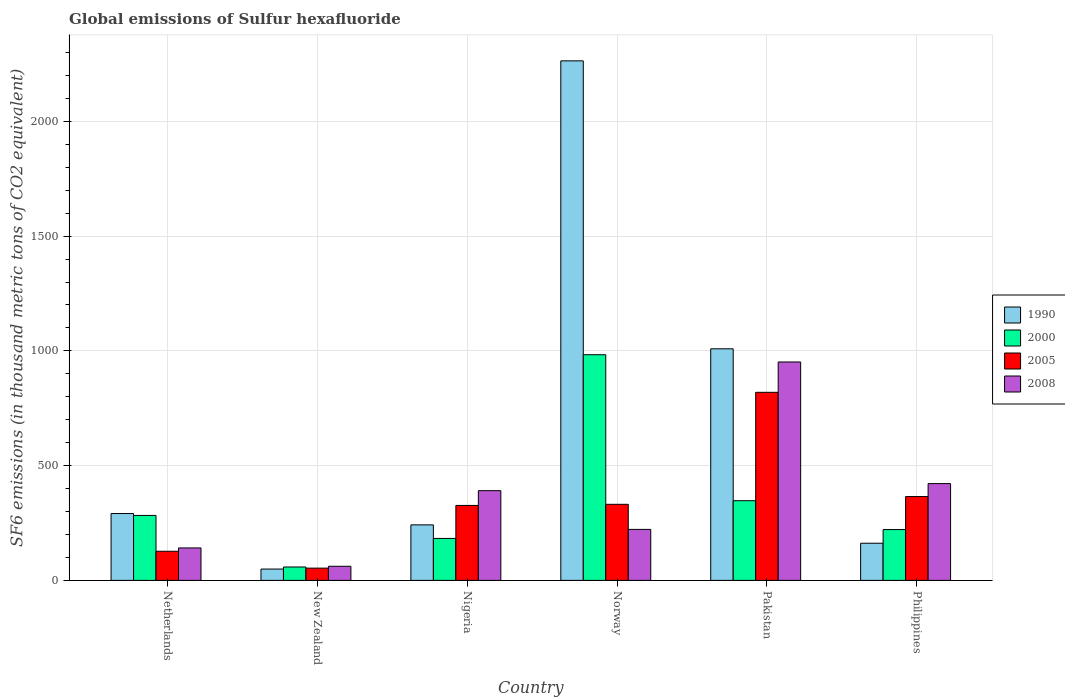How many different coloured bars are there?
Make the answer very short. 4. Are the number of bars per tick equal to the number of legend labels?
Provide a succinct answer. Yes. Are the number of bars on each tick of the X-axis equal?
Make the answer very short. Yes. In how many cases, is the number of bars for a given country not equal to the number of legend labels?
Your answer should be very brief. 0. What is the global emissions of Sulfur hexafluoride in 1990 in Norway?
Keep it short and to the point. 2263.6. Across all countries, what is the maximum global emissions of Sulfur hexafluoride in 2008?
Ensure brevity in your answer.  951.6. Across all countries, what is the minimum global emissions of Sulfur hexafluoride in 2005?
Offer a terse response. 53.4. In which country was the global emissions of Sulfur hexafluoride in 2008 maximum?
Provide a short and direct response. Pakistan. In which country was the global emissions of Sulfur hexafluoride in 1990 minimum?
Your answer should be compact. New Zealand. What is the total global emissions of Sulfur hexafluoride in 2008 in the graph?
Ensure brevity in your answer.  2189.3. What is the difference between the global emissions of Sulfur hexafluoride in 2005 in New Zealand and that in Philippines?
Your answer should be compact. -311.9. What is the difference between the global emissions of Sulfur hexafluoride in 1990 in Philippines and the global emissions of Sulfur hexafluoride in 2000 in New Zealand?
Provide a succinct answer. 103.5. What is the average global emissions of Sulfur hexafluoride in 1990 per country?
Keep it short and to the point. 669.52. What is the difference between the global emissions of Sulfur hexafluoride of/in 1990 and global emissions of Sulfur hexafluoride of/in 2008 in New Zealand?
Provide a succinct answer. -12.1. What is the ratio of the global emissions of Sulfur hexafluoride in 1990 in New Zealand to that in Philippines?
Offer a terse response. 0.31. Is the global emissions of Sulfur hexafluoride in 2000 in Netherlands less than that in New Zealand?
Offer a terse response. No. What is the difference between the highest and the second highest global emissions of Sulfur hexafluoride in 2005?
Offer a very short reply. -488. What is the difference between the highest and the lowest global emissions of Sulfur hexafluoride in 2005?
Offer a very short reply. 766. What does the 1st bar from the right in Nigeria represents?
Offer a terse response. 2008. Is it the case that in every country, the sum of the global emissions of Sulfur hexafluoride in 2008 and global emissions of Sulfur hexafluoride in 2000 is greater than the global emissions of Sulfur hexafluoride in 1990?
Ensure brevity in your answer.  No. How many bars are there?
Your response must be concise. 24. How many countries are there in the graph?
Give a very brief answer. 6. Are the values on the major ticks of Y-axis written in scientific E-notation?
Your answer should be very brief. No. Does the graph contain any zero values?
Offer a very short reply. No. Does the graph contain grids?
Ensure brevity in your answer.  Yes. Where does the legend appear in the graph?
Give a very brief answer. Center right. How are the legend labels stacked?
Ensure brevity in your answer.  Vertical. What is the title of the graph?
Your answer should be very brief. Global emissions of Sulfur hexafluoride. Does "1980" appear as one of the legend labels in the graph?
Your response must be concise. No. What is the label or title of the Y-axis?
Offer a very short reply. SF6 emissions (in thousand metric tons of CO2 equivalent). What is the SF6 emissions (in thousand metric tons of CO2 equivalent) in 1990 in Netherlands?
Your answer should be compact. 291.3. What is the SF6 emissions (in thousand metric tons of CO2 equivalent) of 2000 in Netherlands?
Make the answer very short. 283. What is the SF6 emissions (in thousand metric tons of CO2 equivalent) of 2005 in Netherlands?
Your answer should be compact. 126.9. What is the SF6 emissions (in thousand metric tons of CO2 equivalent) of 2008 in Netherlands?
Your answer should be very brief. 141.4. What is the SF6 emissions (in thousand metric tons of CO2 equivalent) of 1990 in New Zealand?
Offer a very short reply. 49.4. What is the SF6 emissions (in thousand metric tons of CO2 equivalent) in 2000 in New Zealand?
Your answer should be very brief. 58.4. What is the SF6 emissions (in thousand metric tons of CO2 equivalent) of 2005 in New Zealand?
Your answer should be compact. 53.4. What is the SF6 emissions (in thousand metric tons of CO2 equivalent) in 2008 in New Zealand?
Offer a terse response. 61.5. What is the SF6 emissions (in thousand metric tons of CO2 equivalent) of 1990 in Nigeria?
Your answer should be compact. 241.9. What is the SF6 emissions (in thousand metric tons of CO2 equivalent) of 2000 in Nigeria?
Make the answer very short. 182.8. What is the SF6 emissions (in thousand metric tons of CO2 equivalent) in 2005 in Nigeria?
Make the answer very short. 326.6. What is the SF6 emissions (in thousand metric tons of CO2 equivalent) of 2008 in Nigeria?
Provide a succinct answer. 390.9. What is the SF6 emissions (in thousand metric tons of CO2 equivalent) in 1990 in Norway?
Provide a succinct answer. 2263.6. What is the SF6 emissions (in thousand metric tons of CO2 equivalent) in 2000 in Norway?
Offer a terse response. 983.2. What is the SF6 emissions (in thousand metric tons of CO2 equivalent) of 2005 in Norway?
Your response must be concise. 331.4. What is the SF6 emissions (in thousand metric tons of CO2 equivalent) in 2008 in Norway?
Your answer should be very brief. 222.2. What is the SF6 emissions (in thousand metric tons of CO2 equivalent) in 1990 in Pakistan?
Provide a short and direct response. 1009. What is the SF6 emissions (in thousand metric tons of CO2 equivalent) in 2000 in Pakistan?
Ensure brevity in your answer.  347.2. What is the SF6 emissions (in thousand metric tons of CO2 equivalent) of 2005 in Pakistan?
Provide a succinct answer. 819.4. What is the SF6 emissions (in thousand metric tons of CO2 equivalent) of 2008 in Pakistan?
Offer a terse response. 951.6. What is the SF6 emissions (in thousand metric tons of CO2 equivalent) of 1990 in Philippines?
Your answer should be compact. 161.9. What is the SF6 emissions (in thousand metric tons of CO2 equivalent) in 2000 in Philippines?
Offer a very short reply. 221.4. What is the SF6 emissions (in thousand metric tons of CO2 equivalent) of 2005 in Philippines?
Your answer should be compact. 365.3. What is the SF6 emissions (in thousand metric tons of CO2 equivalent) in 2008 in Philippines?
Offer a very short reply. 421.7. Across all countries, what is the maximum SF6 emissions (in thousand metric tons of CO2 equivalent) in 1990?
Offer a very short reply. 2263.6. Across all countries, what is the maximum SF6 emissions (in thousand metric tons of CO2 equivalent) in 2000?
Your answer should be very brief. 983.2. Across all countries, what is the maximum SF6 emissions (in thousand metric tons of CO2 equivalent) of 2005?
Provide a short and direct response. 819.4. Across all countries, what is the maximum SF6 emissions (in thousand metric tons of CO2 equivalent) in 2008?
Keep it short and to the point. 951.6. Across all countries, what is the minimum SF6 emissions (in thousand metric tons of CO2 equivalent) of 1990?
Ensure brevity in your answer.  49.4. Across all countries, what is the minimum SF6 emissions (in thousand metric tons of CO2 equivalent) of 2000?
Offer a very short reply. 58.4. Across all countries, what is the minimum SF6 emissions (in thousand metric tons of CO2 equivalent) of 2005?
Keep it short and to the point. 53.4. Across all countries, what is the minimum SF6 emissions (in thousand metric tons of CO2 equivalent) of 2008?
Your answer should be very brief. 61.5. What is the total SF6 emissions (in thousand metric tons of CO2 equivalent) in 1990 in the graph?
Your answer should be very brief. 4017.1. What is the total SF6 emissions (in thousand metric tons of CO2 equivalent) of 2000 in the graph?
Your answer should be compact. 2076. What is the total SF6 emissions (in thousand metric tons of CO2 equivalent) of 2005 in the graph?
Offer a terse response. 2023. What is the total SF6 emissions (in thousand metric tons of CO2 equivalent) in 2008 in the graph?
Your answer should be compact. 2189.3. What is the difference between the SF6 emissions (in thousand metric tons of CO2 equivalent) of 1990 in Netherlands and that in New Zealand?
Your response must be concise. 241.9. What is the difference between the SF6 emissions (in thousand metric tons of CO2 equivalent) in 2000 in Netherlands and that in New Zealand?
Your answer should be very brief. 224.6. What is the difference between the SF6 emissions (in thousand metric tons of CO2 equivalent) of 2005 in Netherlands and that in New Zealand?
Give a very brief answer. 73.5. What is the difference between the SF6 emissions (in thousand metric tons of CO2 equivalent) of 2008 in Netherlands and that in New Zealand?
Keep it short and to the point. 79.9. What is the difference between the SF6 emissions (in thousand metric tons of CO2 equivalent) in 1990 in Netherlands and that in Nigeria?
Your answer should be compact. 49.4. What is the difference between the SF6 emissions (in thousand metric tons of CO2 equivalent) in 2000 in Netherlands and that in Nigeria?
Keep it short and to the point. 100.2. What is the difference between the SF6 emissions (in thousand metric tons of CO2 equivalent) in 2005 in Netherlands and that in Nigeria?
Your answer should be compact. -199.7. What is the difference between the SF6 emissions (in thousand metric tons of CO2 equivalent) of 2008 in Netherlands and that in Nigeria?
Keep it short and to the point. -249.5. What is the difference between the SF6 emissions (in thousand metric tons of CO2 equivalent) in 1990 in Netherlands and that in Norway?
Give a very brief answer. -1972.3. What is the difference between the SF6 emissions (in thousand metric tons of CO2 equivalent) in 2000 in Netherlands and that in Norway?
Offer a very short reply. -700.2. What is the difference between the SF6 emissions (in thousand metric tons of CO2 equivalent) of 2005 in Netherlands and that in Norway?
Offer a terse response. -204.5. What is the difference between the SF6 emissions (in thousand metric tons of CO2 equivalent) in 2008 in Netherlands and that in Norway?
Make the answer very short. -80.8. What is the difference between the SF6 emissions (in thousand metric tons of CO2 equivalent) of 1990 in Netherlands and that in Pakistan?
Give a very brief answer. -717.7. What is the difference between the SF6 emissions (in thousand metric tons of CO2 equivalent) of 2000 in Netherlands and that in Pakistan?
Offer a very short reply. -64.2. What is the difference between the SF6 emissions (in thousand metric tons of CO2 equivalent) of 2005 in Netherlands and that in Pakistan?
Your answer should be compact. -692.5. What is the difference between the SF6 emissions (in thousand metric tons of CO2 equivalent) in 2008 in Netherlands and that in Pakistan?
Ensure brevity in your answer.  -810.2. What is the difference between the SF6 emissions (in thousand metric tons of CO2 equivalent) of 1990 in Netherlands and that in Philippines?
Ensure brevity in your answer.  129.4. What is the difference between the SF6 emissions (in thousand metric tons of CO2 equivalent) of 2000 in Netherlands and that in Philippines?
Provide a short and direct response. 61.6. What is the difference between the SF6 emissions (in thousand metric tons of CO2 equivalent) of 2005 in Netherlands and that in Philippines?
Your answer should be compact. -238.4. What is the difference between the SF6 emissions (in thousand metric tons of CO2 equivalent) in 2008 in Netherlands and that in Philippines?
Provide a succinct answer. -280.3. What is the difference between the SF6 emissions (in thousand metric tons of CO2 equivalent) in 1990 in New Zealand and that in Nigeria?
Provide a succinct answer. -192.5. What is the difference between the SF6 emissions (in thousand metric tons of CO2 equivalent) of 2000 in New Zealand and that in Nigeria?
Keep it short and to the point. -124.4. What is the difference between the SF6 emissions (in thousand metric tons of CO2 equivalent) of 2005 in New Zealand and that in Nigeria?
Give a very brief answer. -273.2. What is the difference between the SF6 emissions (in thousand metric tons of CO2 equivalent) of 2008 in New Zealand and that in Nigeria?
Provide a succinct answer. -329.4. What is the difference between the SF6 emissions (in thousand metric tons of CO2 equivalent) in 1990 in New Zealand and that in Norway?
Keep it short and to the point. -2214.2. What is the difference between the SF6 emissions (in thousand metric tons of CO2 equivalent) of 2000 in New Zealand and that in Norway?
Offer a terse response. -924.8. What is the difference between the SF6 emissions (in thousand metric tons of CO2 equivalent) in 2005 in New Zealand and that in Norway?
Give a very brief answer. -278. What is the difference between the SF6 emissions (in thousand metric tons of CO2 equivalent) in 2008 in New Zealand and that in Norway?
Your answer should be compact. -160.7. What is the difference between the SF6 emissions (in thousand metric tons of CO2 equivalent) in 1990 in New Zealand and that in Pakistan?
Your response must be concise. -959.6. What is the difference between the SF6 emissions (in thousand metric tons of CO2 equivalent) of 2000 in New Zealand and that in Pakistan?
Your answer should be compact. -288.8. What is the difference between the SF6 emissions (in thousand metric tons of CO2 equivalent) of 2005 in New Zealand and that in Pakistan?
Provide a succinct answer. -766. What is the difference between the SF6 emissions (in thousand metric tons of CO2 equivalent) of 2008 in New Zealand and that in Pakistan?
Your answer should be compact. -890.1. What is the difference between the SF6 emissions (in thousand metric tons of CO2 equivalent) in 1990 in New Zealand and that in Philippines?
Give a very brief answer. -112.5. What is the difference between the SF6 emissions (in thousand metric tons of CO2 equivalent) in 2000 in New Zealand and that in Philippines?
Offer a terse response. -163. What is the difference between the SF6 emissions (in thousand metric tons of CO2 equivalent) of 2005 in New Zealand and that in Philippines?
Ensure brevity in your answer.  -311.9. What is the difference between the SF6 emissions (in thousand metric tons of CO2 equivalent) of 2008 in New Zealand and that in Philippines?
Your answer should be very brief. -360.2. What is the difference between the SF6 emissions (in thousand metric tons of CO2 equivalent) of 1990 in Nigeria and that in Norway?
Offer a very short reply. -2021.7. What is the difference between the SF6 emissions (in thousand metric tons of CO2 equivalent) in 2000 in Nigeria and that in Norway?
Provide a short and direct response. -800.4. What is the difference between the SF6 emissions (in thousand metric tons of CO2 equivalent) in 2005 in Nigeria and that in Norway?
Make the answer very short. -4.8. What is the difference between the SF6 emissions (in thousand metric tons of CO2 equivalent) of 2008 in Nigeria and that in Norway?
Provide a short and direct response. 168.7. What is the difference between the SF6 emissions (in thousand metric tons of CO2 equivalent) of 1990 in Nigeria and that in Pakistan?
Keep it short and to the point. -767.1. What is the difference between the SF6 emissions (in thousand metric tons of CO2 equivalent) of 2000 in Nigeria and that in Pakistan?
Your answer should be compact. -164.4. What is the difference between the SF6 emissions (in thousand metric tons of CO2 equivalent) in 2005 in Nigeria and that in Pakistan?
Your answer should be compact. -492.8. What is the difference between the SF6 emissions (in thousand metric tons of CO2 equivalent) in 2008 in Nigeria and that in Pakistan?
Your answer should be compact. -560.7. What is the difference between the SF6 emissions (in thousand metric tons of CO2 equivalent) of 2000 in Nigeria and that in Philippines?
Ensure brevity in your answer.  -38.6. What is the difference between the SF6 emissions (in thousand metric tons of CO2 equivalent) in 2005 in Nigeria and that in Philippines?
Provide a succinct answer. -38.7. What is the difference between the SF6 emissions (in thousand metric tons of CO2 equivalent) in 2008 in Nigeria and that in Philippines?
Your answer should be very brief. -30.8. What is the difference between the SF6 emissions (in thousand metric tons of CO2 equivalent) in 1990 in Norway and that in Pakistan?
Offer a terse response. 1254.6. What is the difference between the SF6 emissions (in thousand metric tons of CO2 equivalent) of 2000 in Norway and that in Pakistan?
Make the answer very short. 636. What is the difference between the SF6 emissions (in thousand metric tons of CO2 equivalent) in 2005 in Norway and that in Pakistan?
Provide a succinct answer. -488. What is the difference between the SF6 emissions (in thousand metric tons of CO2 equivalent) of 2008 in Norway and that in Pakistan?
Your answer should be compact. -729.4. What is the difference between the SF6 emissions (in thousand metric tons of CO2 equivalent) of 1990 in Norway and that in Philippines?
Your response must be concise. 2101.7. What is the difference between the SF6 emissions (in thousand metric tons of CO2 equivalent) of 2000 in Norway and that in Philippines?
Offer a terse response. 761.8. What is the difference between the SF6 emissions (in thousand metric tons of CO2 equivalent) of 2005 in Norway and that in Philippines?
Provide a succinct answer. -33.9. What is the difference between the SF6 emissions (in thousand metric tons of CO2 equivalent) of 2008 in Norway and that in Philippines?
Keep it short and to the point. -199.5. What is the difference between the SF6 emissions (in thousand metric tons of CO2 equivalent) of 1990 in Pakistan and that in Philippines?
Ensure brevity in your answer.  847.1. What is the difference between the SF6 emissions (in thousand metric tons of CO2 equivalent) of 2000 in Pakistan and that in Philippines?
Your answer should be compact. 125.8. What is the difference between the SF6 emissions (in thousand metric tons of CO2 equivalent) of 2005 in Pakistan and that in Philippines?
Give a very brief answer. 454.1. What is the difference between the SF6 emissions (in thousand metric tons of CO2 equivalent) in 2008 in Pakistan and that in Philippines?
Offer a very short reply. 529.9. What is the difference between the SF6 emissions (in thousand metric tons of CO2 equivalent) of 1990 in Netherlands and the SF6 emissions (in thousand metric tons of CO2 equivalent) of 2000 in New Zealand?
Offer a terse response. 232.9. What is the difference between the SF6 emissions (in thousand metric tons of CO2 equivalent) in 1990 in Netherlands and the SF6 emissions (in thousand metric tons of CO2 equivalent) in 2005 in New Zealand?
Offer a very short reply. 237.9. What is the difference between the SF6 emissions (in thousand metric tons of CO2 equivalent) in 1990 in Netherlands and the SF6 emissions (in thousand metric tons of CO2 equivalent) in 2008 in New Zealand?
Your answer should be very brief. 229.8. What is the difference between the SF6 emissions (in thousand metric tons of CO2 equivalent) in 2000 in Netherlands and the SF6 emissions (in thousand metric tons of CO2 equivalent) in 2005 in New Zealand?
Keep it short and to the point. 229.6. What is the difference between the SF6 emissions (in thousand metric tons of CO2 equivalent) in 2000 in Netherlands and the SF6 emissions (in thousand metric tons of CO2 equivalent) in 2008 in New Zealand?
Provide a short and direct response. 221.5. What is the difference between the SF6 emissions (in thousand metric tons of CO2 equivalent) of 2005 in Netherlands and the SF6 emissions (in thousand metric tons of CO2 equivalent) of 2008 in New Zealand?
Provide a succinct answer. 65.4. What is the difference between the SF6 emissions (in thousand metric tons of CO2 equivalent) in 1990 in Netherlands and the SF6 emissions (in thousand metric tons of CO2 equivalent) in 2000 in Nigeria?
Your answer should be compact. 108.5. What is the difference between the SF6 emissions (in thousand metric tons of CO2 equivalent) of 1990 in Netherlands and the SF6 emissions (in thousand metric tons of CO2 equivalent) of 2005 in Nigeria?
Provide a succinct answer. -35.3. What is the difference between the SF6 emissions (in thousand metric tons of CO2 equivalent) in 1990 in Netherlands and the SF6 emissions (in thousand metric tons of CO2 equivalent) in 2008 in Nigeria?
Your response must be concise. -99.6. What is the difference between the SF6 emissions (in thousand metric tons of CO2 equivalent) of 2000 in Netherlands and the SF6 emissions (in thousand metric tons of CO2 equivalent) of 2005 in Nigeria?
Provide a short and direct response. -43.6. What is the difference between the SF6 emissions (in thousand metric tons of CO2 equivalent) in 2000 in Netherlands and the SF6 emissions (in thousand metric tons of CO2 equivalent) in 2008 in Nigeria?
Your answer should be compact. -107.9. What is the difference between the SF6 emissions (in thousand metric tons of CO2 equivalent) of 2005 in Netherlands and the SF6 emissions (in thousand metric tons of CO2 equivalent) of 2008 in Nigeria?
Your answer should be compact. -264. What is the difference between the SF6 emissions (in thousand metric tons of CO2 equivalent) of 1990 in Netherlands and the SF6 emissions (in thousand metric tons of CO2 equivalent) of 2000 in Norway?
Give a very brief answer. -691.9. What is the difference between the SF6 emissions (in thousand metric tons of CO2 equivalent) of 1990 in Netherlands and the SF6 emissions (in thousand metric tons of CO2 equivalent) of 2005 in Norway?
Give a very brief answer. -40.1. What is the difference between the SF6 emissions (in thousand metric tons of CO2 equivalent) of 1990 in Netherlands and the SF6 emissions (in thousand metric tons of CO2 equivalent) of 2008 in Norway?
Your answer should be compact. 69.1. What is the difference between the SF6 emissions (in thousand metric tons of CO2 equivalent) of 2000 in Netherlands and the SF6 emissions (in thousand metric tons of CO2 equivalent) of 2005 in Norway?
Your answer should be compact. -48.4. What is the difference between the SF6 emissions (in thousand metric tons of CO2 equivalent) of 2000 in Netherlands and the SF6 emissions (in thousand metric tons of CO2 equivalent) of 2008 in Norway?
Offer a terse response. 60.8. What is the difference between the SF6 emissions (in thousand metric tons of CO2 equivalent) in 2005 in Netherlands and the SF6 emissions (in thousand metric tons of CO2 equivalent) in 2008 in Norway?
Your answer should be compact. -95.3. What is the difference between the SF6 emissions (in thousand metric tons of CO2 equivalent) of 1990 in Netherlands and the SF6 emissions (in thousand metric tons of CO2 equivalent) of 2000 in Pakistan?
Offer a terse response. -55.9. What is the difference between the SF6 emissions (in thousand metric tons of CO2 equivalent) in 1990 in Netherlands and the SF6 emissions (in thousand metric tons of CO2 equivalent) in 2005 in Pakistan?
Ensure brevity in your answer.  -528.1. What is the difference between the SF6 emissions (in thousand metric tons of CO2 equivalent) of 1990 in Netherlands and the SF6 emissions (in thousand metric tons of CO2 equivalent) of 2008 in Pakistan?
Provide a succinct answer. -660.3. What is the difference between the SF6 emissions (in thousand metric tons of CO2 equivalent) in 2000 in Netherlands and the SF6 emissions (in thousand metric tons of CO2 equivalent) in 2005 in Pakistan?
Your response must be concise. -536.4. What is the difference between the SF6 emissions (in thousand metric tons of CO2 equivalent) of 2000 in Netherlands and the SF6 emissions (in thousand metric tons of CO2 equivalent) of 2008 in Pakistan?
Ensure brevity in your answer.  -668.6. What is the difference between the SF6 emissions (in thousand metric tons of CO2 equivalent) in 2005 in Netherlands and the SF6 emissions (in thousand metric tons of CO2 equivalent) in 2008 in Pakistan?
Give a very brief answer. -824.7. What is the difference between the SF6 emissions (in thousand metric tons of CO2 equivalent) in 1990 in Netherlands and the SF6 emissions (in thousand metric tons of CO2 equivalent) in 2000 in Philippines?
Keep it short and to the point. 69.9. What is the difference between the SF6 emissions (in thousand metric tons of CO2 equivalent) in 1990 in Netherlands and the SF6 emissions (in thousand metric tons of CO2 equivalent) in 2005 in Philippines?
Your answer should be very brief. -74. What is the difference between the SF6 emissions (in thousand metric tons of CO2 equivalent) of 1990 in Netherlands and the SF6 emissions (in thousand metric tons of CO2 equivalent) of 2008 in Philippines?
Offer a terse response. -130.4. What is the difference between the SF6 emissions (in thousand metric tons of CO2 equivalent) of 2000 in Netherlands and the SF6 emissions (in thousand metric tons of CO2 equivalent) of 2005 in Philippines?
Keep it short and to the point. -82.3. What is the difference between the SF6 emissions (in thousand metric tons of CO2 equivalent) of 2000 in Netherlands and the SF6 emissions (in thousand metric tons of CO2 equivalent) of 2008 in Philippines?
Offer a very short reply. -138.7. What is the difference between the SF6 emissions (in thousand metric tons of CO2 equivalent) in 2005 in Netherlands and the SF6 emissions (in thousand metric tons of CO2 equivalent) in 2008 in Philippines?
Your response must be concise. -294.8. What is the difference between the SF6 emissions (in thousand metric tons of CO2 equivalent) of 1990 in New Zealand and the SF6 emissions (in thousand metric tons of CO2 equivalent) of 2000 in Nigeria?
Provide a short and direct response. -133.4. What is the difference between the SF6 emissions (in thousand metric tons of CO2 equivalent) in 1990 in New Zealand and the SF6 emissions (in thousand metric tons of CO2 equivalent) in 2005 in Nigeria?
Your answer should be very brief. -277.2. What is the difference between the SF6 emissions (in thousand metric tons of CO2 equivalent) in 1990 in New Zealand and the SF6 emissions (in thousand metric tons of CO2 equivalent) in 2008 in Nigeria?
Ensure brevity in your answer.  -341.5. What is the difference between the SF6 emissions (in thousand metric tons of CO2 equivalent) of 2000 in New Zealand and the SF6 emissions (in thousand metric tons of CO2 equivalent) of 2005 in Nigeria?
Keep it short and to the point. -268.2. What is the difference between the SF6 emissions (in thousand metric tons of CO2 equivalent) of 2000 in New Zealand and the SF6 emissions (in thousand metric tons of CO2 equivalent) of 2008 in Nigeria?
Keep it short and to the point. -332.5. What is the difference between the SF6 emissions (in thousand metric tons of CO2 equivalent) in 2005 in New Zealand and the SF6 emissions (in thousand metric tons of CO2 equivalent) in 2008 in Nigeria?
Make the answer very short. -337.5. What is the difference between the SF6 emissions (in thousand metric tons of CO2 equivalent) of 1990 in New Zealand and the SF6 emissions (in thousand metric tons of CO2 equivalent) of 2000 in Norway?
Make the answer very short. -933.8. What is the difference between the SF6 emissions (in thousand metric tons of CO2 equivalent) of 1990 in New Zealand and the SF6 emissions (in thousand metric tons of CO2 equivalent) of 2005 in Norway?
Keep it short and to the point. -282. What is the difference between the SF6 emissions (in thousand metric tons of CO2 equivalent) of 1990 in New Zealand and the SF6 emissions (in thousand metric tons of CO2 equivalent) of 2008 in Norway?
Keep it short and to the point. -172.8. What is the difference between the SF6 emissions (in thousand metric tons of CO2 equivalent) in 2000 in New Zealand and the SF6 emissions (in thousand metric tons of CO2 equivalent) in 2005 in Norway?
Provide a succinct answer. -273. What is the difference between the SF6 emissions (in thousand metric tons of CO2 equivalent) in 2000 in New Zealand and the SF6 emissions (in thousand metric tons of CO2 equivalent) in 2008 in Norway?
Provide a short and direct response. -163.8. What is the difference between the SF6 emissions (in thousand metric tons of CO2 equivalent) of 2005 in New Zealand and the SF6 emissions (in thousand metric tons of CO2 equivalent) of 2008 in Norway?
Offer a very short reply. -168.8. What is the difference between the SF6 emissions (in thousand metric tons of CO2 equivalent) of 1990 in New Zealand and the SF6 emissions (in thousand metric tons of CO2 equivalent) of 2000 in Pakistan?
Provide a short and direct response. -297.8. What is the difference between the SF6 emissions (in thousand metric tons of CO2 equivalent) of 1990 in New Zealand and the SF6 emissions (in thousand metric tons of CO2 equivalent) of 2005 in Pakistan?
Make the answer very short. -770. What is the difference between the SF6 emissions (in thousand metric tons of CO2 equivalent) in 1990 in New Zealand and the SF6 emissions (in thousand metric tons of CO2 equivalent) in 2008 in Pakistan?
Provide a succinct answer. -902.2. What is the difference between the SF6 emissions (in thousand metric tons of CO2 equivalent) of 2000 in New Zealand and the SF6 emissions (in thousand metric tons of CO2 equivalent) of 2005 in Pakistan?
Ensure brevity in your answer.  -761. What is the difference between the SF6 emissions (in thousand metric tons of CO2 equivalent) of 2000 in New Zealand and the SF6 emissions (in thousand metric tons of CO2 equivalent) of 2008 in Pakistan?
Your answer should be compact. -893.2. What is the difference between the SF6 emissions (in thousand metric tons of CO2 equivalent) of 2005 in New Zealand and the SF6 emissions (in thousand metric tons of CO2 equivalent) of 2008 in Pakistan?
Provide a succinct answer. -898.2. What is the difference between the SF6 emissions (in thousand metric tons of CO2 equivalent) in 1990 in New Zealand and the SF6 emissions (in thousand metric tons of CO2 equivalent) in 2000 in Philippines?
Offer a very short reply. -172. What is the difference between the SF6 emissions (in thousand metric tons of CO2 equivalent) of 1990 in New Zealand and the SF6 emissions (in thousand metric tons of CO2 equivalent) of 2005 in Philippines?
Offer a very short reply. -315.9. What is the difference between the SF6 emissions (in thousand metric tons of CO2 equivalent) in 1990 in New Zealand and the SF6 emissions (in thousand metric tons of CO2 equivalent) in 2008 in Philippines?
Offer a terse response. -372.3. What is the difference between the SF6 emissions (in thousand metric tons of CO2 equivalent) in 2000 in New Zealand and the SF6 emissions (in thousand metric tons of CO2 equivalent) in 2005 in Philippines?
Your response must be concise. -306.9. What is the difference between the SF6 emissions (in thousand metric tons of CO2 equivalent) of 2000 in New Zealand and the SF6 emissions (in thousand metric tons of CO2 equivalent) of 2008 in Philippines?
Ensure brevity in your answer.  -363.3. What is the difference between the SF6 emissions (in thousand metric tons of CO2 equivalent) in 2005 in New Zealand and the SF6 emissions (in thousand metric tons of CO2 equivalent) in 2008 in Philippines?
Offer a terse response. -368.3. What is the difference between the SF6 emissions (in thousand metric tons of CO2 equivalent) in 1990 in Nigeria and the SF6 emissions (in thousand metric tons of CO2 equivalent) in 2000 in Norway?
Provide a short and direct response. -741.3. What is the difference between the SF6 emissions (in thousand metric tons of CO2 equivalent) in 1990 in Nigeria and the SF6 emissions (in thousand metric tons of CO2 equivalent) in 2005 in Norway?
Keep it short and to the point. -89.5. What is the difference between the SF6 emissions (in thousand metric tons of CO2 equivalent) in 1990 in Nigeria and the SF6 emissions (in thousand metric tons of CO2 equivalent) in 2008 in Norway?
Make the answer very short. 19.7. What is the difference between the SF6 emissions (in thousand metric tons of CO2 equivalent) of 2000 in Nigeria and the SF6 emissions (in thousand metric tons of CO2 equivalent) of 2005 in Norway?
Provide a succinct answer. -148.6. What is the difference between the SF6 emissions (in thousand metric tons of CO2 equivalent) of 2000 in Nigeria and the SF6 emissions (in thousand metric tons of CO2 equivalent) of 2008 in Norway?
Make the answer very short. -39.4. What is the difference between the SF6 emissions (in thousand metric tons of CO2 equivalent) of 2005 in Nigeria and the SF6 emissions (in thousand metric tons of CO2 equivalent) of 2008 in Norway?
Your answer should be compact. 104.4. What is the difference between the SF6 emissions (in thousand metric tons of CO2 equivalent) in 1990 in Nigeria and the SF6 emissions (in thousand metric tons of CO2 equivalent) in 2000 in Pakistan?
Give a very brief answer. -105.3. What is the difference between the SF6 emissions (in thousand metric tons of CO2 equivalent) of 1990 in Nigeria and the SF6 emissions (in thousand metric tons of CO2 equivalent) of 2005 in Pakistan?
Offer a very short reply. -577.5. What is the difference between the SF6 emissions (in thousand metric tons of CO2 equivalent) in 1990 in Nigeria and the SF6 emissions (in thousand metric tons of CO2 equivalent) in 2008 in Pakistan?
Provide a succinct answer. -709.7. What is the difference between the SF6 emissions (in thousand metric tons of CO2 equivalent) of 2000 in Nigeria and the SF6 emissions (in thousand metric tons of CO2 equivalent) of 2005 in Pakistan?
Provide a short and direct response. -636.6. What is the difference between the SF6 emissions (in thousand metric tons of CO2 equivalent) of 2000 in Nigeria and the SF6 emissions (in thousand metric tons of CO2 equivalent) of 2008 in Pakistan?
Offer a terse response. -768.8. What is the difference between the SF6 emissions (in thousand metric tons of CO2 equivalent) in 2005 in Nigeria and the SF6 emissions (in thousand metric tons of CO2 equivalent) in 2008 in Pakistan?
Ensure brevity in your answer.  -625. What is the difference between the SF6 emissions (in thousand metric tons of CO2 equivalent) in 1990 in Nigeria and the SF6 emissions (in thousand metric tons of CO2 equivalent) in 2005 in Philippines?
Provide a succinct answer. -123.4. What is the difference between the SF6 emissions (in thousand metric tons of CO2 equivalent) of 1990 in Nigeria and the SF6 emissions (in thousand metric tons of CO2 equivalent) of 2008 in Philippines?
Your answer should be very brief. -179.8. What is the difference between the SF6 emissions (in thousand metric tons of CO2 equivalent) of 2000 in Nigeria and the SF6 emissions (in thousand metric tons of CO2 equivalent) of 2005 in Philippines?
Your response must be concise. -182.5. What is the difference between the SF6 emissions (in thousand metric tons of CO2 equivalent) in 2000 in Nigeria and the SF6 emissions (in thousand metric tons of CO2 equivalent) in 2008 in Philippines?
Keep it short and to the point. -238.9. What is the difference between the SF6 emissions (in thousand metric tons of CO2 equivalent) in 2005 in Nigeria and the SF6 emissions (in thousand metric tons of CO2 equivalent) in 2008 in Philippines?
Your answer should be compact. -95.1. What is the difference between the SF6 emissions (in thousand metric tons of CO2 equivalent) in 1990 in Norway and the SF6 emissions (in thousand metric tons of CO2 equivalent) in 2000 in Pakistan?
Make the answer very short. 1916.4. What is the difference between the SF6 emissions (in thousand metric tons of CO2 equivalent) in 1990 in Norway and the SF6 emissions (in thousand metric tons of CO2 equivalent) in 2005 in Pakistan?
Give a very brief answer. 1444.2. What is the difference between the SF6 emissions (in thousand metric tons of CO2 equivalent) in 1990 in Norway and the SF6 emissions (in thousand metric tons of CO2 equivalent) in 2008 in Pakistan?
Your answer should be very brief. 1312. What is the difference between the SF6 emissions (in thousand metric tons of CO2 equivalent) in 2000 in Norway and the SF6 emissions (in thousand metric tons of CO2 equivalent) in 2005 in Pakistan?
Make the answer very short. 163.8. What is the difference between the SF6 emissions (in thousand metric tons of CO2 equivalent) in 2000 in Norway and the SF6 emissions (in thousand metric tons of CO2 equivalent) in 2008 in Pakistan?
Your answer should be compact. 31.6. What is the difference between the SF6 emissions (in thousand metric tons of CO2 equivalent) in 2005 in Norway and the SF6 emissions (in thousand metric tons of CO2 equivalent) in 2008 in Pakistan?
Your response must be concise. -620.2. What is the difference between the SF6 emissions (in thousand metric tons of CO2 equivalent) in 1990 in Norway and the SF6 emissions (in thousand metric tons of CO2 equivalent) in 2000 in Philippines?
Offer a very short reply. 2042.2. What is the difference between the SF6 emissions (in thousand metric tons of CO2 equivalent) in 1990 in Norway and the SF6 emissions (in thousand metric tons of CO2 equivalent) in 2005 in Philippines?
Make the answer very short. 1898.3. What is the difference between the SF6 emissions (in thousand metric tons of CO2 equivalent) of 1990 in Norway and the SF6 emissions (in thousand metric tons of CO2 equivalent) of 2008 in Philippines?
Provide a short and direct response. 1841.9. What is the difference between the SF6 emissions (in thousand metric tons of CO2 equivalent) of 2000 in Norway and the SF6 emissions (in thousand metric tons of CO2 equivalent) of 2005 in Philippines?
Provide a succinct answer. 617.9. What is the difference between the SF6 emissions (in thousand metric tons of CO2 equivalent) of 2000 in Norway and the SF6 emissions (in thousand metric tons of CO2 equivalent) of 2008 in Philippines?
Provide a short and direct response. 561.5. What is the difference between the SF6 emissions (in thousand metric tons of CO2 equivalent) in 2005 in Norway and the SF6 emissions (in thousand metric tons of CO2 equivalent) in 2008 in Philippines?
Provide a short and direct response. -90.3. What is the difference between the SF6 emissions (in thousand metric tons of CO2 equivalent) in 1990 in Pakistan and the SF6 emissions (in thousand metric tons of CO2 equivalent) in 2000 in Philippines?
Make the answer very short. 787.6. What is the difference between the SF6 emissions (in thousand metric tons of CO2 equivalent) of 1990 in Pakistan and the SF6 emissions (in thousand metric tons of CO2 equivalent) of 2005 in Philippines?
Offer a terse response. 643.7. What is the difference between the SF6 emissions (in thousand metric tons of CO2 equivalent) in 1990 in Pakistan and the SF6 emissions (in thousand metric tons of CO2 equivalent) in 2008 in Philippines?
Offer a terse response. 587.3. What is the difference between the SF6 emissions (in thousand metric tons of CO2 equivalent) in 2000 in Pakistan and the SF6 emissions (in thousand metric tons of CO2 equivalent) in 2005 in Philippines?
Ensure brevity in your answer.  -18.1. What is the difference between the SF6 emissions (in thousand metric tons of CO2 equivalent) of 2000 in Pakistan and the SF6 emissions (in thousand metric tons of CO2 equivalent) of 2008 in Philippines?
Provide a succinct answer. -74.5. What is the difference between the SF6 emissions (in thousand metric tons of CO2 equivalent) in 2005 in Pakistan and the SF6 emissions (in thousand metric tons of CO2 equivalent) in 2008 in Philippines?
Ensure brevity in your answer.  397.7. What is the average SF6 emissions (in thousand metric tons of CO2 equivalent) in 1990 per country?
Provide a succinct answer. 669.52. What is the average SF6 emissions (in thousand metric tons of CO2 equivalent) in 2000 per country?
Ensure brevity in your answer.  346. What is the average SF6 emissions (in thousand metric tons of CO2 equivalent) of 2005 per country?
Your answer should be compact. 337.17. What is the average SF6 emissions (in thousand metric tons of CO2 equivalent) in 2008 per country?
Your response must be concise. 364.88. What is the difference between the SF6 emissions (in thousand metric tons of CO2 equivalent) in 1990 and SF6 emissions (in thousand metric tons of CO2 equivalent) in 2005 in Netherlands?
Give a very brief answer. 164.4. What is the difference between the SF6 emissions (in thousand metric tons of CO2 equivalent) in 1990 and SF6 emissions (in thousand metric tons of CO2 equivalent) in 2008 in Netherlands?
Offer a terse response. 149.9. What is the difference between the SF6 emissions (in thousand metric tons of CO2 equivalent) of 2000 and SF6 emissions (in thousand metric tons of CO2 equivalent) of 2005 in Netherlands?
Ensure brevity in your answer.  156.1. What is the difference between the SF6 emissions (in thousand metric tons of CO2 equivalent) of 2000 and SF6 emissions (in thousand metric tons of CO2 equivalent) of 2008 in Netherlands?
Make the answer very short. 141.6. What is the difference between the SF6 emissions (in thousand metric tons of CO2 equivalent) of 1990 and SF6 emissions (in thousand metric tons of CO2 equivalent) of 2008 in New Zealand?
Provide a short and direct response. -12.1. What is the difference between the SF6 emissions (in thousand metric tons of CO2 equivalent) of 2000 and SF6 emissions (in thousand metric tons of CO2 equivalent) of 2005 in New Zealand?
Your response must be concise. 5. What is the difference between the SF6 emissions (in thousand metric tons of CO2 equivalent) in 1990 and SF6 emissions (in thousand metric tons of CO2 equivalent) in 2000 in Nigeria?
Offer a very short reply. 59.1. What is the difference between the SF6 emissions (in thousand metric tons of CO2 equivalent) in 1990 and SF6 emissions (in thousand metric tons of CO2 equivalent) in 2005 in Nigeria?
Make the answer very short. -84.7. What is the difference between the SF6 emissions (in thousand metric tons of CO2 equivalent) of 1990 and SF6 emissions (in thousand metric tons of CO2 equivalent) of 2008 in Nigeria?
Provide a succinct answer. -149. What is the difference between the SF6 emissions (in thousand metric tons of CO2 equivalent) of 2000 and SF6 emissions (in thousand metric tons of CO2 equivalent) of 2005 in Nigeria?
Offer a terse response. -143.8. What is the difference between the SF6 emissions (in thousand metric tons of CO2 equivalent) of 2000 and SF6 emissions (in thousand metric tons of CO2 equivalent) of 2008 in Nigeria?
Your response must be concise. -208.1. What is the difference between the SF6 emissions (in thousand metric tons of CO2 equivalent) of 2005 and SF6 emissions (in thousand metric tons of CO2 equivalent) of 2008 in Nigeria?
Offer a very short reply. -64.3. What is the difference between the SF6 emissions (in thousand metric tons of CO2 equivalent) in 1990 and SF6 emissions (in thousand metric tons of CO2 equivalent) in 2000 in Norway?
Provide a short and direct response. 1280.4. What is the difference between the SF6 emissions (in thousand metric tons of CO2 equivalent) of 1990 and SF6 emissions (in thousand metric tons of CO2 equivalent) of 2005 in Norway?
Provide a succinct answer. 1932.2. What is the difference between the SF6 emissions (in thousand metric tons of CO2 equivalent) in 1990 and SF6 emissions (in thousand metric tons of CO2 equivalent) in 2008 in Norway?
Give a very brief answer. 2041.4. What is the difference between the SF6 emissions (in thousand metric tons of CO2 equivalent) in 2000 and SF6 emissions (in thousand metric tons of CO2 equivalent) in 2005 in Norway?
Ensure brevity in your answer.  651.8. What is the difference between the SF6 emissions (in thousand metric tons of CO2 equivalent) of 2000 and SF6 emissions (in thousand metric tons of CO2 equivalent) of 2008 in Norway?
Ensure brevity in your answer.  761. What is the difference between the SF6 emissions (in thousand metric tons of CO2 equivalent) in 2005 and SF6 emissions (in thousand metric tons of CO2 equivalent) in 2008 in Norway?
Your response must be concise. 109.2. What is the difference between the SF6 emissions (in thousand metric tons of CO2 equivalent) of 1990 and SF6 emissions (in thousand metric tons of CO2 equivalent) of 2000 in Pakistan?
Give a very brief answer. 661.8. What is the difference between the SF6 emissions (in thousand metric tons of CO2 equivalent) in 1990 and SF6 emissions (in thousand metric tons of CO2 equivalent) in 2005 in Pakistan?
Keep it short and to the point. 189.6. What is the difference between the SF6 emissions (in thousand metric tons of CO2 equivalent) in 1990 and SF6 emissions (in thousand metric tons of CO2 equivalent) in 2008 in Pakistan?
Your answer should be very brief. 57.4. What is the difference between the SF6 emissions (in thousand metric tons of CO2 equivalent) in 2000 and SF6 emissions (in thousand metric tons of CO2 equivalent) in 2005 in Pakistan?
Keep it short and to the point. -472.2. What is the difference between the SF6 emissions (in thousand metric tons of CO2 equivalent) in 2000 and SF6 emissions (in thousand metric tons of CO2 equivalent) in 2008 in Pakistan?
Your answer should be compact. -604.4. What is the difference between the SF6 emissions (in thousand metric tons of CO2 equivalent) in 2005 and SF6 emissions (in thousand metric tons of CO2 equivalent) in 2008 in Pakistan?
Give a very brief answer. -132.2. What is the difference between the SF6 emissions (in thousand metric tons of CO2 equivalent) of 1990 and SF6 emissions (in thousand metric tons of CO2 equivalent) of 2000 in Philippines?
Ensure brevity in your answer.  -59.5. What is the difference between the SF6 emissions (in thousand metric tons of CO2 equivalent) in 1990 and SF6 emissions (in thousand metric tons of CO2 equivalent) in 2005 in Philippines?
Give a very brief answer. -203.4. What is the difference between the SF6 emissions (in thousand metric tons of CO2 equivalent) of 1990 and SF6 emissions (in thousand metric tons of CO2 equivalent) of 2008 in Philippines?
Give a very brief answer. -259.8. What is the difference between the SF6 emissions (in thousand metric tons of CO2 equivalent) in 2000 and SF6 emissions (in thousand metric tons of CO2 equivalent) in 2005 in Philippines?
Your answer should be very brief. -143.9. What is the difference between the SF6 emissions (in thousand metric tons of CO2 equivalent) of 2000 and SF6 emissions (in thousand metric tons of CO2 equivalent) of 2008 in Philippines?
Ensure brevity in your answer.  -200.3. What is the difference between the SF6 emissions (in thousand metric tons of CO2 equivalent) in 2005 and SF6 emissions (in thousand metric tons of CO2 equivalent) in 2008 in Philippines?
Offer a terse response. -56.4. What is the ratio of the SF6 emissions (in thousand metric tons of CO2 equivalent) of 1990 in Netherlands to that in New Zealand?
Your answer should be compact. 5.9. What is the ratio of the SF6 emissions (in thousand metric tons of CO2 equivalent) of 2000 in Netherlands to that in New Zealand?
Your answer should be very brief. 4.85. What is the ratio of the SF6 emissions (in thousand metric tons of CO2 equivalent) in 2005 in Netherlands to that in New Zealand?
Provide a short and direct response. 2.38. What is the ratio of the SF6 emissions (in thousand metric tons of CO2 equivalent) in 2008 in Netherlands to that in New Zealand?
Provide a succinct answer. 2.3. What is the ratio of the SF6 emissions (in thousand metric tons of CO2 equivalent) in 1990 in Netherlands to that in Nigeria?
Keep it short and to the point. 1.2. What is the ratio of the SF6 emissions (in thousand metric tons of CO2 equivalent) in 2000 in Netherlands to that in Nigeria?
Make the answer very short. 1.55. What is the ratio of the SF6 emissions (in thousand metric tons of CO2 equivalent) of 2005 in Netherlands to that in Nigeria?
Offer a terse response. 0.39. What is the ratio of the SF6 emissions (in thousand metric tons of CO2 equivalent) in 2008 in Netherlands to that in Nigeria?
Give a very brief answer. 0.36. What is the ratio of the SF6 emissions (in thousand metric tons of CO2 equivalent) in 1990 in Netherlands to that in Norway?
Give a very brief answer. 0.13. What is the ratio of the SF6 emissions (in thousand metric tons of CO2 equivalent) of 2000 in Netherlands to that in Norway?
Give a very brief answer. 0.29. What is the ratio of the SF6 emissions (in thousand metric tons of CO2 equivalent) of 2005 in Netherlands to that in Norway?
Your answer should be very brief. 0.38. What is the ratio of the SF6 emissions (in thousand metric tons of CO2 equivalent) of 2008 in Netherlands to that in Norway?
Make the answer very short. 0.64. What is the ratio of the SF6 emissions (in thousand metric tons of CO2 equivalent) of 1990 in Netherlands to that in Pakistan?
Keep it short and to the point. 0.29. What is the ratio of the SF6 emissions (in thousand metric tons of CO2 equivalent) in 2000 in Netherlands to that in Pakistan?
Ensure brevity in your answer.  0.82. What is the ratio of the SF6 emissions (in thousand metric tons of CO2 equivalent) in 2005 in Netherlands to that in Pakistan?
Your answer should be very brief. 0.15. What is the ratio of the SF6 emissions (in thousand metric tons of CO2 equivalent) in 2008 in Netherlands to that in Pakistan?
Offer a very short reply. 0.15. What is the ratio of the SF6 emissions (in thousand metric tons of CO2 equivalent) of 1990 in Netherlands to that in Philippines?
Your answer should be compact. 1.8. What is the ratio of the SF6 emissions (in thousand metric tons of CO2 equivalent) in 2000 in Netherlands to that in Philippines?
Your response must be concise. 1.28. What is the ratio of the SF6 emissions (in thousand metric tons of CO2 equivalent) of 2005 in Netherlands to that in Philippines?
Your response must be concise. 0.35. What is the ratio of the SF6 emissions (in thousand metric tons of CO2 equivalent) of 2008 in Netherlands to that in Philippines?
Provide a short and direct response. 0.34. What is the ratio of the SF6 emissions (in thousand metric tons of CO2 equivalent) in 1990 in New Zealand to that in Nigeria?
Your response must be concise. 0.2. What is the ratio of the SF6 emissions (in thousand metric tons of CO2 equivalent) in 2000 in New Zealand to that in Nigeria?
Provide a succinct answer. 0.32. What is the ratio of the SF6 emissions (in thousand metric tons of CO2 equivalent) of 2005 in New Zealand to that in Nigeria?
Provide a succinct answer. 0.16. What is the ratio of the SF6 emissions (in thousand metric tons of CO2 equivalent) in 2008 in New Zealand to that in Nigeria?
Provide a succinct answer. 0.16. What is the ratio of the SF6 emissions (in thousand metric tons of CO2 equivalent) of 1990 in New Zealand to that in Norway?
Make the answer very short. 0.02. What is the ratio of the SF6 emissions (in thousand metric tons of CO2 equivalent) of 2000 in New Zealand to that in Norway?
Offer a terse response. 0.06. What is the ratio of the SF6 emissions (in thousand metric tons of CO2 equivalent) in 2005 in New Zealand to that in Norway?
Provide a short and direct response. 0.16. What is the ratio of the SF6 emissions (in thousand metric tons of CO2 equivalent) of 2008 in New Zealand to that in Norway?
Offer a terse response. 0.28. What is the ratio of the SF6 emissions (in thousand metric tons of CO2 equivalent) in 1990 in New Zealand to that in Pakistan?
Offer a very short reply. 0.05. What is the ratio of the SF6 emissions (in thousand metric tons of CO2 equivalent) of 2000 in New Zealand to that in Pakistan?
Offer a terse response. 0.17. What is the ratio of the SF6 emissions (in thousand metric tons of CO2 equivalent) in 2005 in New Zealand to that in Pakistan?
Offer a terse response. 0.07. What is the ratio of the SF6 emissions (in thousand metric tons of CO2 equivalent) in 2008 in New Zealand to that in Pakistan?
Offer a very short reply. 0.06. What is the ratio of the SF6 emissions (in thousand metric tons of CO2 equivalent) in 1990 in New Zealand to that in Philippines?
Offer a very short reply. 0.31. What is the ratio of the SF6 emissions (in thousand metric tons of CO2 equivalent) of 2000 in New Zealand to that in Philippines?
Your answer should be compact. 0.26. What is the ratio of the SF6 emissions (in thousand metric tons of CO2 equivalent) in 2005 in New Zealand to that in Philippines?
Provide a succinct answer. 0.15. What is the ratio of the SF6 emissions (in thousand metric tons of CO2 equivalent) of 2008 in New Zealand to that in Philippines?
Provide a succinct answer. 0.15. What is the ratio of the SF6 emissions (in thousand metric tons of CO2 equivalent) of 1990 in Nigeria to that in Norway?
Provide a succinct answer. 0.11. What is the ratio of the SF6 emissions (in thousand metric tons of CO2 equivalent) of 2000 in Nigeria to that in Norway?
Keep it short and to the point. 0.19. What is the ratio of the SF6 emissions (in thousand metric tons of CO2 equivalent) in 2005 in Nigeria to that in Norway?
Offer a terse response. 0.99. What is the ratio of the SF6 emissions (in thousand metric tons of CO2 equivalent) in 2008 in Nigeria to that in Norway?
Provide a succinct answer. 1.76. What is the ratio of the SF6 emissions (in thousand metric tons of CO2 equivalent) in 1990 in Nigeria to that in Pakistan?
Your answer should be compact. 0.24. What is the ratio of the SF6 emissions (in thousand metric tons of CO2 equivalent) of 2000 in Nigeria to that in Pakistan?
Your answer should be compact. 0.53. What is the ratio of the SF6 emissions (in thousand metric tons of CO2 equivalent) of 2005 in Nigeria to that in Pakistan?
Your response must be concise. 0.4. What is the ratio of the SF6 emissions (in thousand metric tons of CO2 equivalent) in 2008 in Nigeria to that in Pakistan?
Provide a short and direct response. 0.41. What is the ratio of the SF6 emissions (in thousand metric tons of CO2 equivalent) in 1990 in Nigeria to that in Philippines?
Provide a succinct answer. 1.49. What is the ratio of the SF6 emissions (in thousand metric tons of CO2 equivalent) in 2000 in Nigeria to that in Philippines?
Your answer should be very brief. 0.83. What is the ratio of the SF6 emissions (in thousand metric tons of CO2 equivalent) of 2005 in Nigeria to that in Philippines?
Offer a terse response. 0.89. What is the ratio of the SF6 emissions (in thousand metric tons of CO2 equivalent) in 2008 in Nigeria to that in Philippines?
Provide a succinct answer. 0.93. What is the ratio of the SF6 emissions (in thousand metric tons of CO2 equivalent) in 1990 in Norway to that in Pakistan?
Offer a terse response. 2.24. What is the ratio of the SF6 emissions (in thousand metric tons of CO2 equivalent) in 2000 in Norway to that in Pakistan?
Ensure brevity in your answer.  2.83. What is the ratio of the SF6 emissions (in thousand metric tons of CO2 equivalent) of 2005 in Norway to that in Pakistan?
Your answer should be very brief. 0.4. What is the ratio of the SF6 emissions (in thousand metric tons of CO2 equivalent) of 2008 in Norway to that in Pakistan?
Ensure brevity in your answer.  0.23. What is the ratio of the SF6 emissions (in thousand metric tons of CO2 equivalent) of 1990 in Norway to that in Philippines?
Offer a very short reply. 13.98. What is the ratio of the SF6 emissions (in thousand metric tons of CO2 equivalent) in 2000 in Norway to that in Philippines?
Offer a terse response. 4.44. What is the ratio of the SF6 emissions (in thousand metric tons of CO2 equivalent) of 2005 in Norway to that in Philippines?
Offer a very short reply. 0.91. What is the ratio of the SF6 emissions (in thousand metric tons of CO2 equivalent) of 2008 in Norway to that in Philippines?
Ensure brevity in your answer.  0.53. What is the ratio of the SF6 emissions (in thousand metric tons of CO2 equivalent) in 1990 in Pakistan to that in Philippines?
Offer a very short reply. 6.23. What is the ratio of the SF6 emissions (in thousand metric tons of CO2 equivalent) in 2000 in Pakistan to that in Philippines?
Make the answer very short. 1.57. What is the ratio of the SF6 emissions (in thousand metric tons of CO2 equivalent) of 2005 in Pakistan to that in Philippines?
Keep it short and to the point. 2.24. What is the ratio of the SF6 emissions (in thousand metric tons of CO2 equivalent) in 2008 in Pakistan to that in Philippines?
Make the answer very short. 2.26. What is the difference between the highest and the second highest SF6 emissions (in thousand metric tons of CO2 equivalent) of 1990?
Provide a short and direct response. 1254.6. What is the difference between the highest and the second highest SF6 emissions (in thousand metric tons of CO2 equivalent) of 2000?
Provide a short and direct response. 636. What is the difference between the highest and the second highest SF6 emissions (in thousand metric tons of CO2 equivalent) of 2005?
Provide a short and direct response. 454.1. What is the difference between the highest and the second highest SF6 emissions (in thousand metric tons of CO2 equivalent) in 2008?
Make the answer very short. 529.9. What is the difference between the highest and the lowest SF6 emissions (in thousand metric tons of CO2 equivalent) of 1990?
Provide a succinct answer. 2214.2. What is the difference between the highest and the lowest SF6 emissions (in thousand metric tons of CO2 equivalent) of 2000?
Provide a succinct answer. 924.8. What is the difference between the highest and the lowest SF6 emissions (in thousand metric tons of CO2 equivalent) of 2005?
Offer a terse response. 766. What is the difference between the highest and the lowest SF6 emissions (in thousand metric tons of CO2 equivalent) in 2008?
Your answer should be compact. 890.1. 